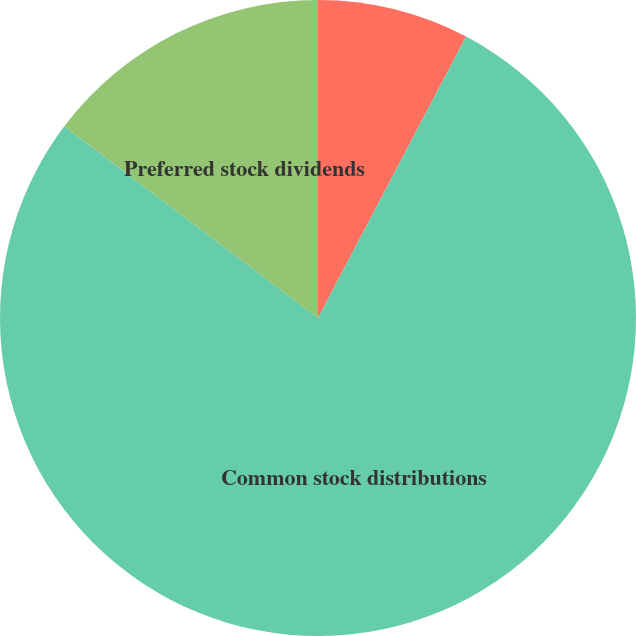<chart> <loc_0><loc_0><loc_500><loc_500><pie_chart><fcel>December 31<fcel>Common stock distributions<fcel>Preferred stock dividends<nl><fcel>7.71%<fcel>77.59%<fcel>14.7%<nl></chart> 